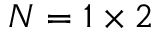<formula> <loc_0><loc_0><loc_500><loc_500>N = 1 \times 2</formula> 